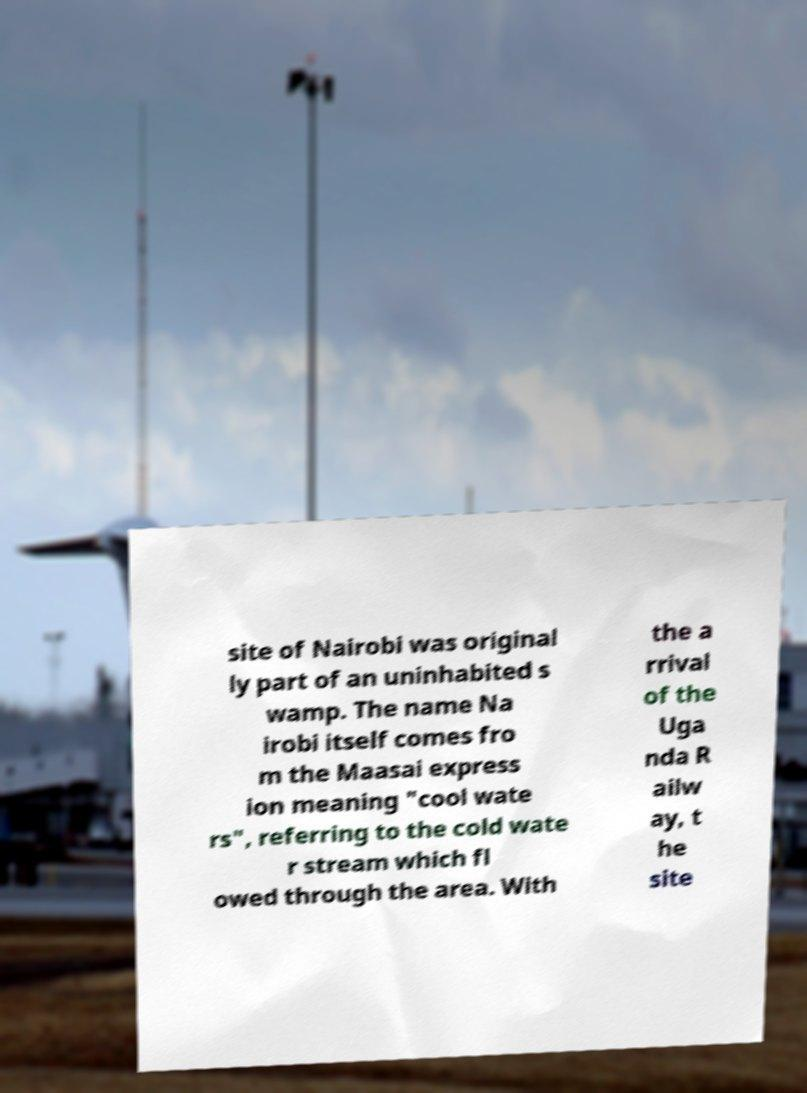Can you accurately transcribe the text from the provided image for me? site of Nairobi was original ly part of an uninhabited s wamp. The name Na irobi itself comes fro m the Maasai express ion meaning "cool wate rs", referring to the cold wate r stream which fl owed through the area. With the a rrival of the Uga nda R ailw ay, t he site 